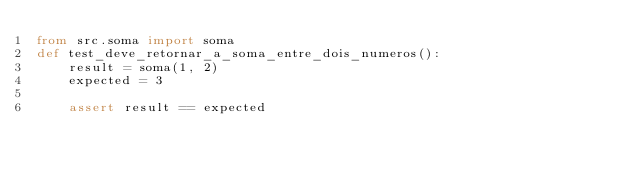Convert code to text. <code><loc_0><loc_0><loc_500><loc_500><_Python_>from src.soma import soma
def test_deve_retornar_a_soma_entre_dois_numeros():
    result = soma(1, 2)
    expected = 3

    assert result == expected
</code> 